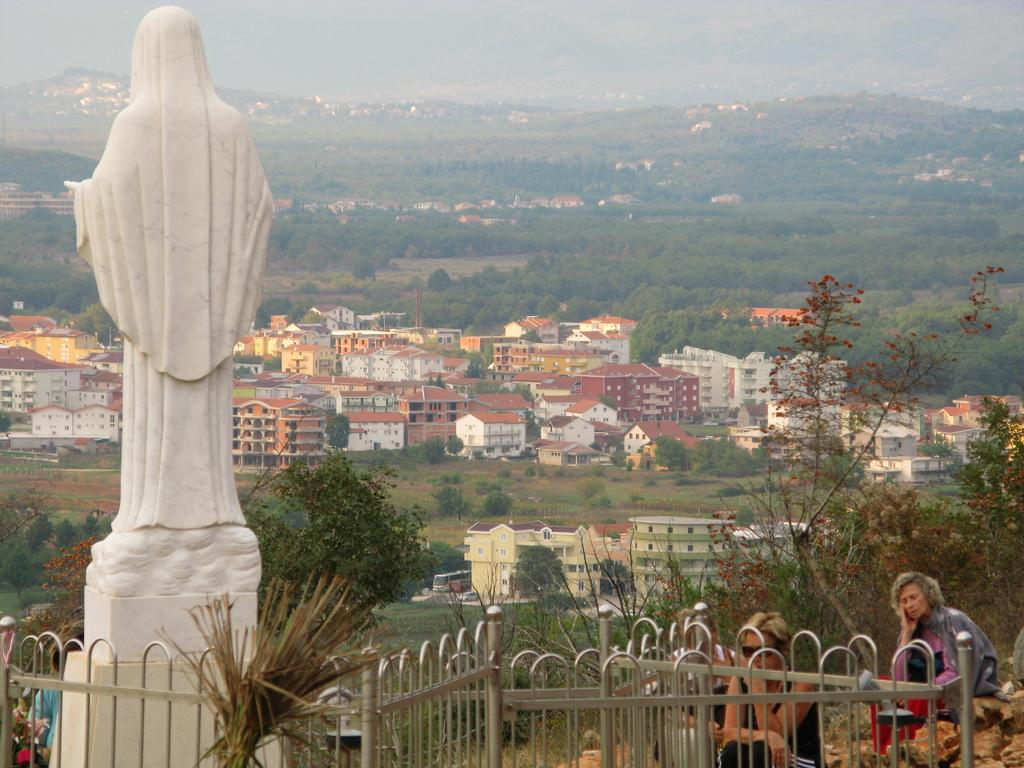What is the main subject of subject of the image? There is a white-colored sculpture in the image. Are there any other elements in the image besides the sculpture? Yes, there are people in the image. What can be seen in the background of the image? There are trees and buildings in the background of the image. What type of lace is being used to decorate the sculpture in the image? There is no lace present on the sculpture in the image. Can you tell me how many tricks the people in the image are performing? There is no indication of any tricks being performed by the people in the image. 